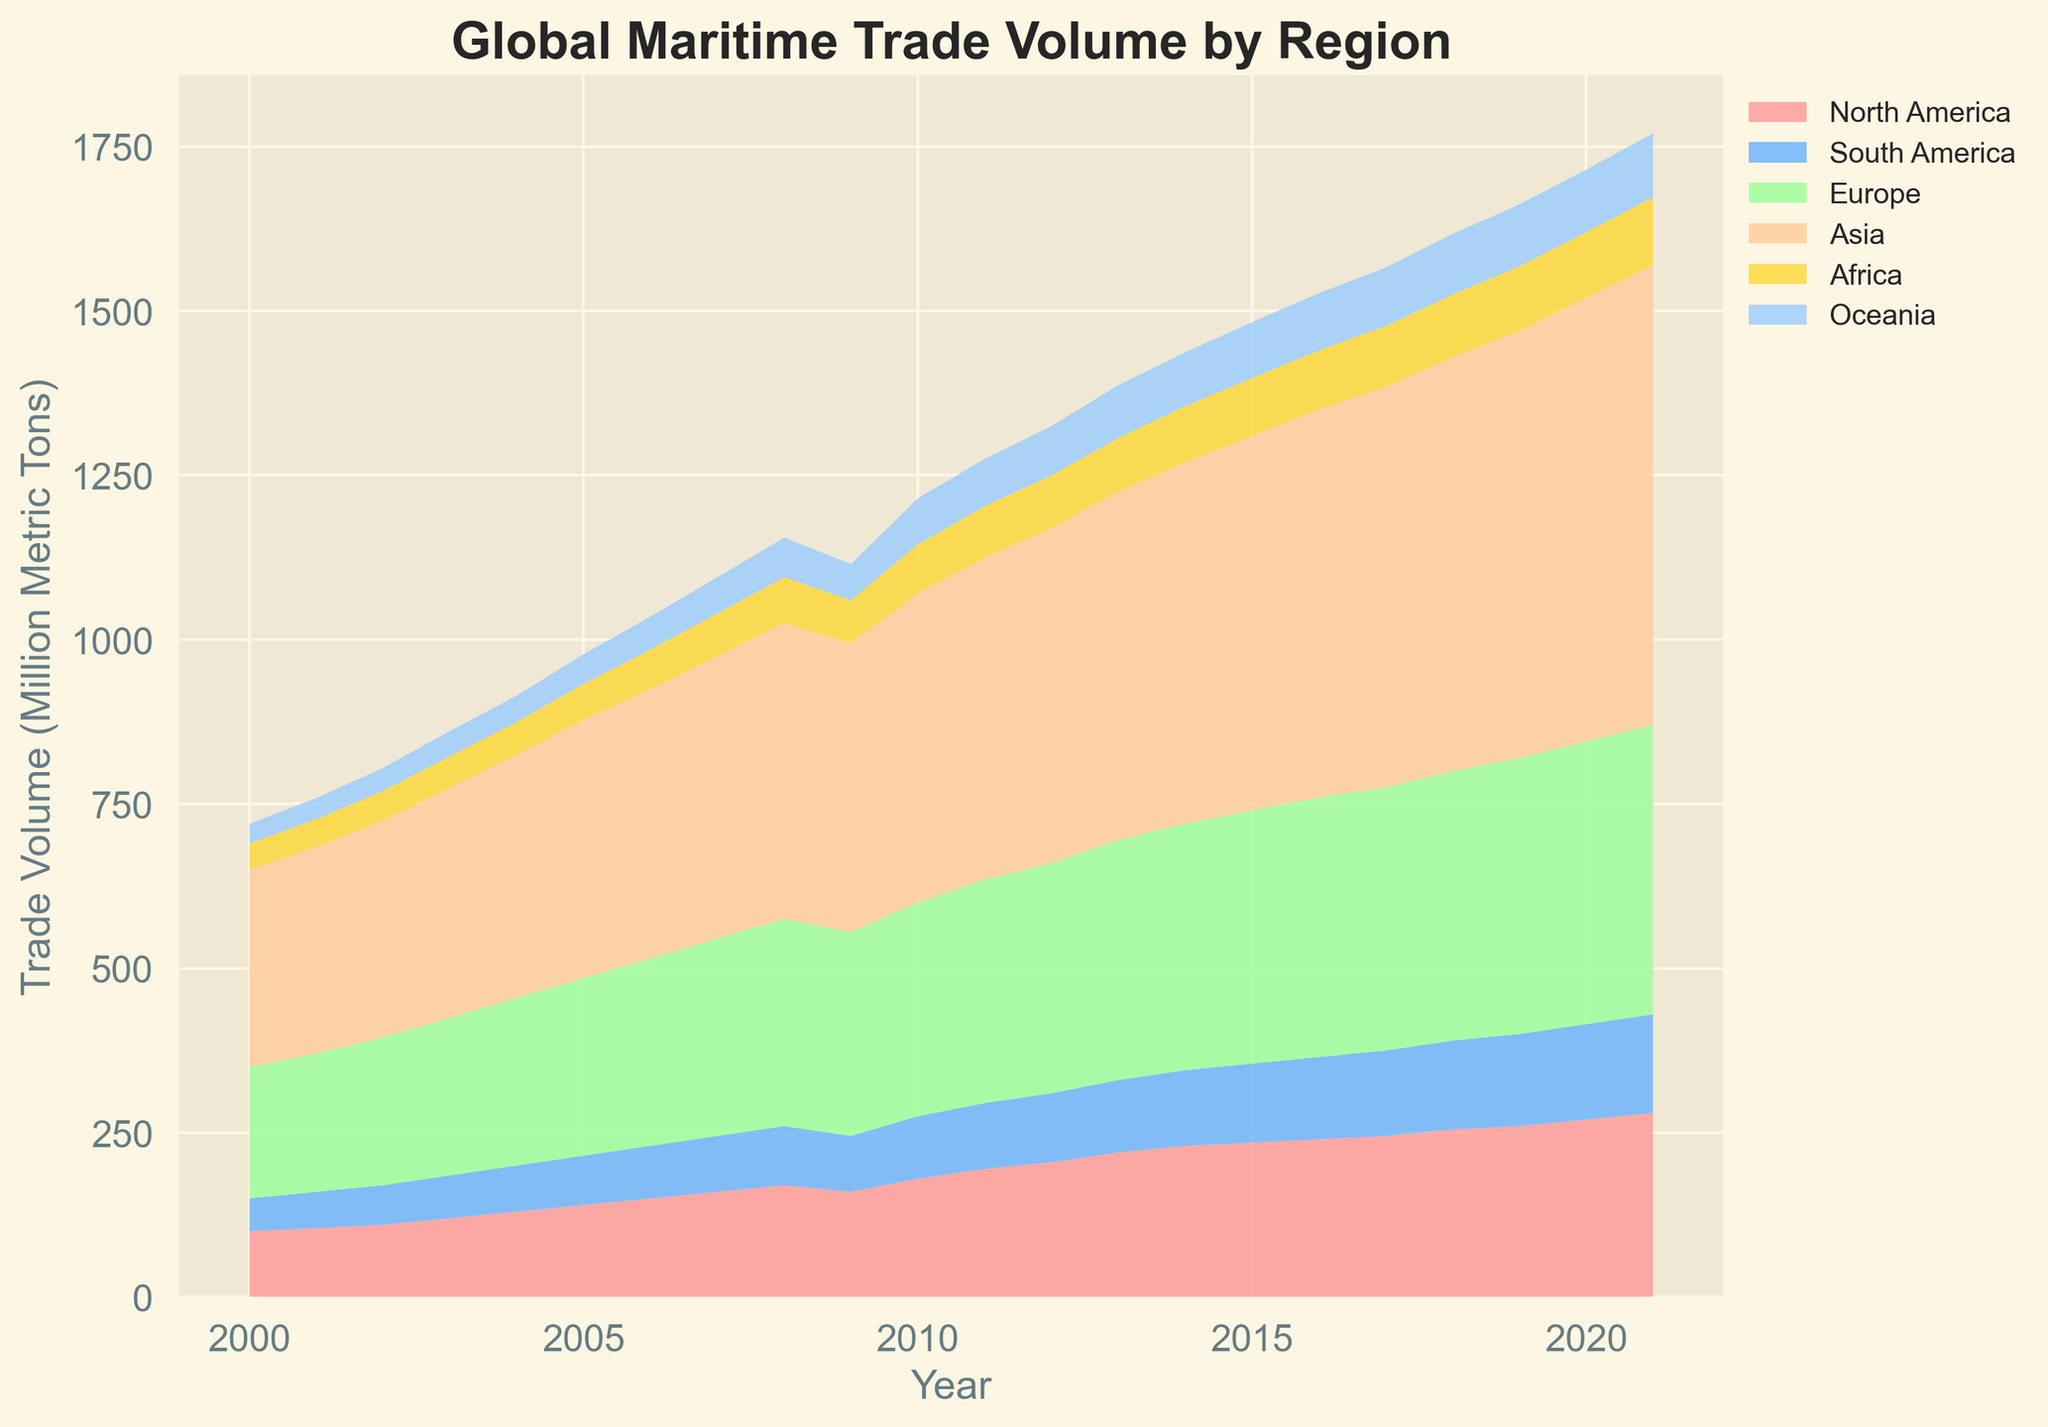Which region has the highest trade volume in 2000? By looking at the bottom-most area in the chart for the year 2000, we see that Asia has the largest area section. Hence, Asia has the highest trade volume.
Answer: Asia How did the trade volume in North America change from 2005 to 2020? To find the change, we subtract the volume of North America in 2005 from the volume in 2020. From the figure, in 2005 the volume is represented at a certain height and in 2020 it's higher. So, the increase is from 140 to 270, which is 270 - 140.
Answer: Increased by 130 Between 2010 and 2015, which region showed the largest increase in trade volume? Comparing the height of the stacked areas for each region between 2010 and 2015, we can see that Asia has the most significant increase in height, showing the largest growth.
Answer: Asia How did the total global trade volume change from 2015 to 2021? The total height of the entire stacked area in the chart represents the total trade volume. Between 2015 and 2021, the height of the stacked areas has increased from 1483 to 1770. Therefore, the total change is 1770 - 1483.
Answer: Increased by 287 Which two regions have similar trade volumes in 2015? Observing the heights of the respective stacked areas in 2015 for each region, it appears that Africa and Oceania have similar heights, indicating similar trade volumes.
Answer: Africa and Oceania When did Oceania surpass 80 million metric tons in trade volume? By looking at the particular color-coded area for Oceania, we can see that it surpasses the line corresponding to 80 million metric tons around the year 2011.
Answer: 2011 What is the combined trade volume for Europe and Asia in 2008? To find the combined volume, we add the volumes for Europe (315) and Asia (450) in 2008 by visually interpreting the heights for each region. So, 315 + 450.
Answer: 765 During which year did South America first exceed 100 million metric tons? By examining the area corresponding to South America, we notice that by the year 2011, South America exceeds the 100 million metric tons mark.
Answer: 2011 What is the proportion of trade represented by Africa in 2020 compared to the total global trade volume in that year? Africa's trade volume in 2020 is shown as 100 million metric tons out of a total global trade volume of 1715. To find the proportion, we calculate (100/1715)*100 to get the percentage.
Answer: Approximately 5.83% Which region had the least growth from 2000 to 2021? By visually comparing the changes in area size for each region from 2000 to 2021, Oceania shows the smallest vertical increase, indicating the least growth.
Answer: Oceania 